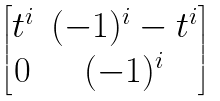Convert formula to latex. <formula><loc_0><loc_0><loc_500><loc_500>\begin{bmatrix} t ^ { i } & ( - 1 ) ^ { i } - t ^ { i } \\ 0 & ( - 1 ) ^ { i } \end{bmatrix}</formula> 